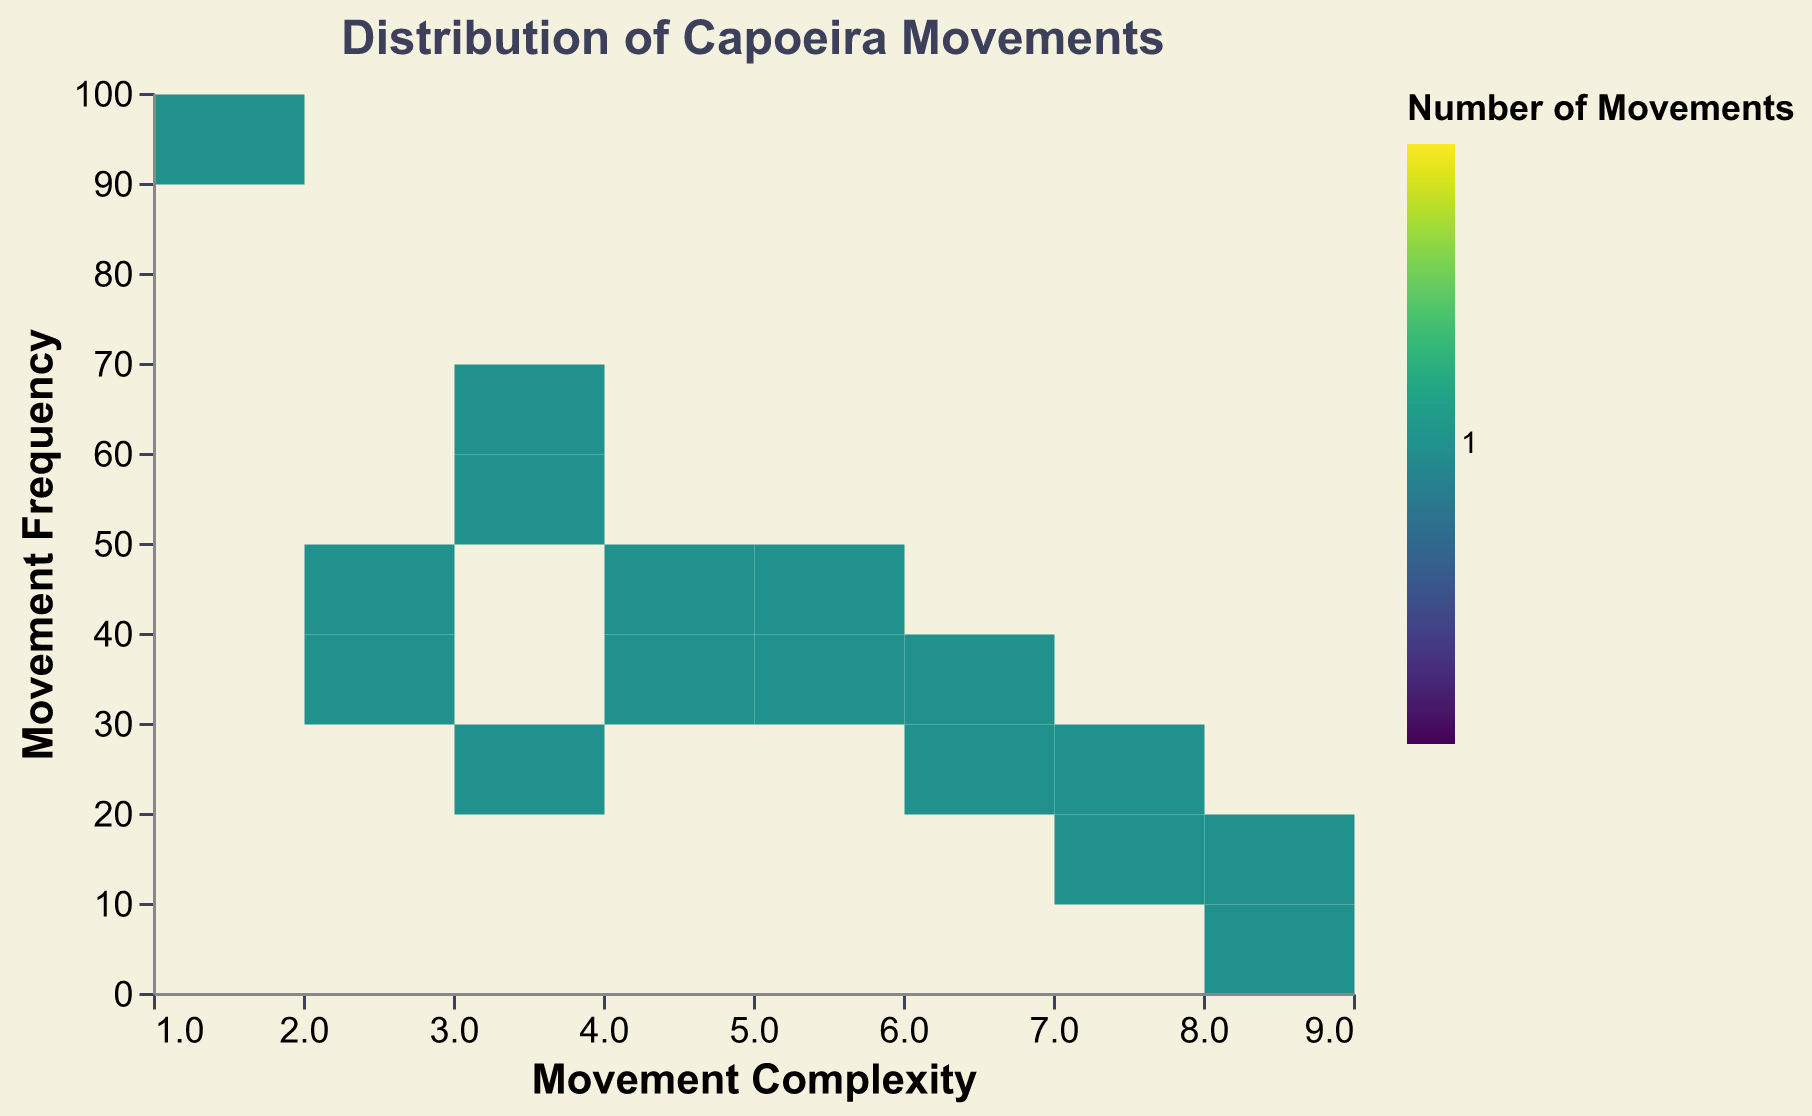What's the title of the plot? The title is typically positioned at the top of the plot. The title here is "Distribution of Capoeira Movements".
Answer: Distribution of Capoeira Movements What does the color represent in the plot? According to the legend, the color indicates the "Number of Movements". The more saturated colors imply a higher number of movements within a bin.
Answer: Number of Movements Which skill level has the movement with the highest frequency? By examining the plot, we can find that the highest frequency is 95 and corresponds to the movement "Ginga", which is in the "Beginner" skill level.
Answer: Beginner How does complexity typically change with skill level? Observing the movement complexity on the x-axis in association with skill levels, we see that complexity generally increases as the skill level progresses from Beginner to Master.
Answer: Increases Which complexity level has the highest frequency of movements? The highest frequency observed is 95, corresponding to a complexity level of 1. Thus, the complexity level of 1 has the highest frequency of movements.
Answer: 1 Which bins show the highest number of movements? Darker colors in the plot indicate a higher number of movements within a bin. The bin at Complexity 1 and Frequency 95 is the darkest, indicating the highest number of movements.
Answer: Complexity 1, Frequency 95 How many movements are in the highest complexity bin? The highest complexity bin is 9 (Pião de Mão). By observing the color, see that there is 1 movement, since it is less saturated than other bins.
Answer: 1 Which movement has the lowest frequency among Masters? By filtering the data to only show the Master skill level, the movement with the lowest frequency of 5 is Pião de Mão.
Answer: Pião de Mão Compare the frequency of "Meia Lua de Frente" and "Meia Lua de Compasso". Which one is higher and by how much? Meia Lua de Frente (Intermediate) has a frequency of 60, while Meia Lua de Compasso (Advanced) has a frequency of 40. The difference is 20.
Answer: Meia Lua de Frente by 20 Identify the movement with the maximum frequency and its corresponding complexity. The movement with the maximum frequency is Ginga with a frequency of 95 and a complexity of 1.
Answer: Ginga, Complexity 1 